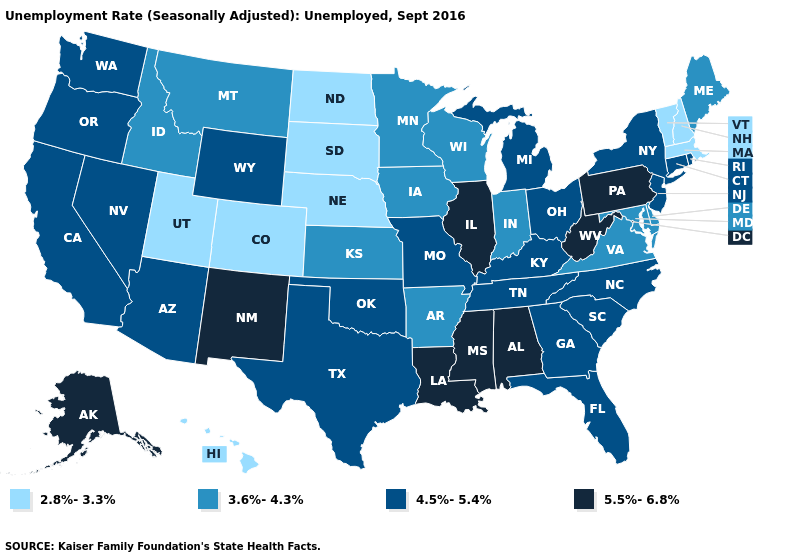Among the states that border New Jersey , which have the highest value?
Quick response, please. Pennsylvania. What is the value of Vermont?
Concise answer only. 2.8%-3.3%. Does Oregon have the same value as Tennessee?
Be succinct. Yes. Name the states that have a value in the range 5.5%-6.8%?
Concise answer only. Alabama, Alaska, Illinois, Louisiana, Mississippi, New Mexico, Pennsylvania, West Virginia. Name the states that have a value in the range 4.5%-5.4%?
Be succinct. Arizona, California, Connecticut, Florida, Georgia, Kentucky, Michigan, Missouri, Nevada, New Jersey, New York, North Carolina, Ohio, Oklahoma, Oregon, Rhode Island, South Carolina, Tennessee, Texas, Washington, Wyoming. Name the states that have a value in the range 4.5%-5.4%?
Keep it brief. Arizona, California, Connecticut, Florida, Georgia, Kentucky, Michigan, Missouri, Nevada, New Jersey, New York, North Carolina, Ohio, Oklahoma, Oregon, Rhode Island, South Carolina, Tennessee, Texas, Washington, Wyoming. What is the value of Nevada?
Concise answer only. 4.5%-5.4%. What is the lowest value in the USA?
Short answer required. 2.8%-3.3%. What is the value of Alaska?
Answer briefly. 5.5%-6.8%. Does Alabama have the lowest value in the South?
Concise answer only. No. What is the value of Wyoming?
Write a very short answer. 4.5%-5.4%. Name the states that have a value in the range 4.5%-5.4%?
Keep it brief. Arizona, California, Connecticut, Florida, Georgia, Kentucky, Michigan, Missouri, Nevada, New Jersey, New York, North Carolina, Ohio, Oklahoma, Oregon, Rhode Island, South Carolina, Tennessee, Texas, Washington, Wyoming. Name the states that have a value in the range 2.8%-3.3%?
Keep it brief. Colorado, Hawaii, Massachusetts, Nebraska, New Hampshire, North Dakota, South Dakota, Utah, Vermont. What is the value of Wyoming?
Quick response, please. 4.5%-5.4%. 